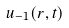<formula> <loc_0><loc_0><loc_500><loc_500>u _ { - 1 } ( r , t )</formula> 